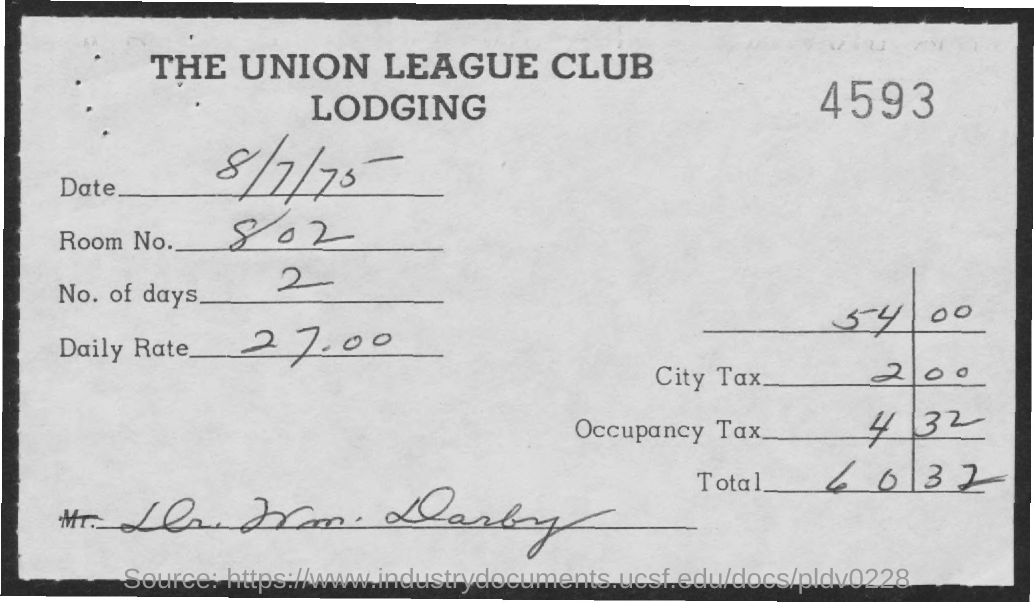Indicate a few pertinent items in this graphic. The city tax is 2.00... The total is 60.32 dollars. The room number is 802. The first title in the document is 'The union league club.' The number at the top right of the document is 4593. 